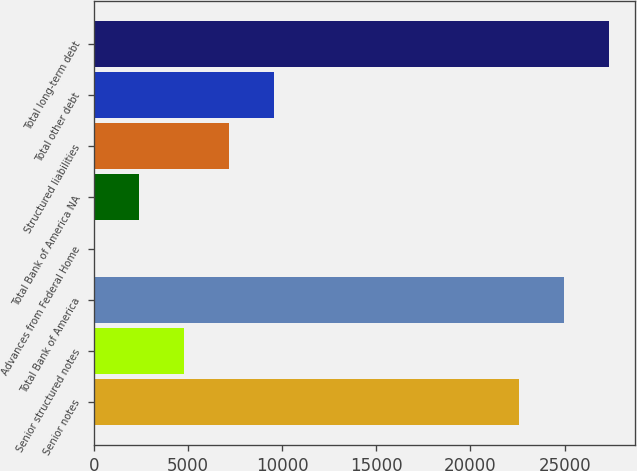Convert chart to OTSL. <chart><loc_0><loc_0><loc_500><loc_500><bar_chart><fcel>Senior notes<fcel>Senior structured notes<fcel>Total Bank of America<fcel>Advances from Federal Home<fcel>Total Bank of America NA<fcel>Structured liabilities<fcel>Total other debt<fcel>Total long-term debt<nl><fcel>22570<fcel>4776.8<fcel>24957.9<fcel>1<fcel>2388.9<fcel>7164.7<fcel>9552.6<fcel>27345.8<nl></chart> 